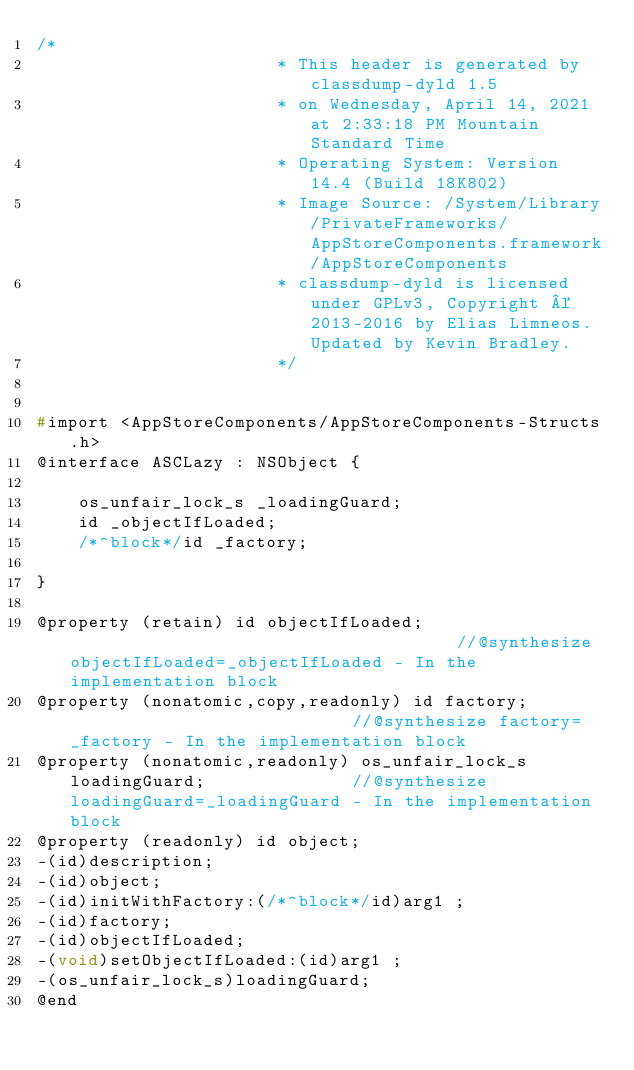<code> <loc_0><loc_0><loc_500><loc_500><_C_>/*
                       * This header is generated by classdump-dyld 1.5
                       * on Wednesday, April 14, 2021 at 2:33:18 PM Mountain Standard Time
                       * Operating System: Version 14.4 (Build 18K802)
                       * Image Source: /System/Library/PrivateFrameworks/AppStoreComponents.framework/AppStoreComponents
                       * classdump-dyld is licensed under GPLv3, Copyright © 2013-2016 by Elias Limneos. Updated by Kevin Bradley.
                       */


#import <AppStoreComponents/AppStoreComponents-Structs.h>
@interface ASCLazy : NSObject {

	os_unfair_lock_s _loadingGuard;
	id _objectIfLoaded;
	/*^block*/id _factory;

}

@property (retain) id objectIfLoaded;                                      //@synthesize objectIfLoaded=_objectIfLoaded - In the implementation block
@property (nonatomic,copy,readonly) id factory;                            //@synthesize factory=_factory - In the implementation block
@property (nonatomic,readonly) os_unfair_lock_s loadingGuard;              //@synthesize loadingGuard=_loadingGuard - In the implementation block
@property (readonly) id object; 
-(id)description;
-(id)object;
-(id)initWithFactory:(/*^block*/id)arg1 ;
-(id)factory;
-(id)objectIfLoaded;
-(void)setObjectIfLoaded:(id)arg1 ;
-(os_unfair_lock_s)loadingGuard;
@end

</code> 